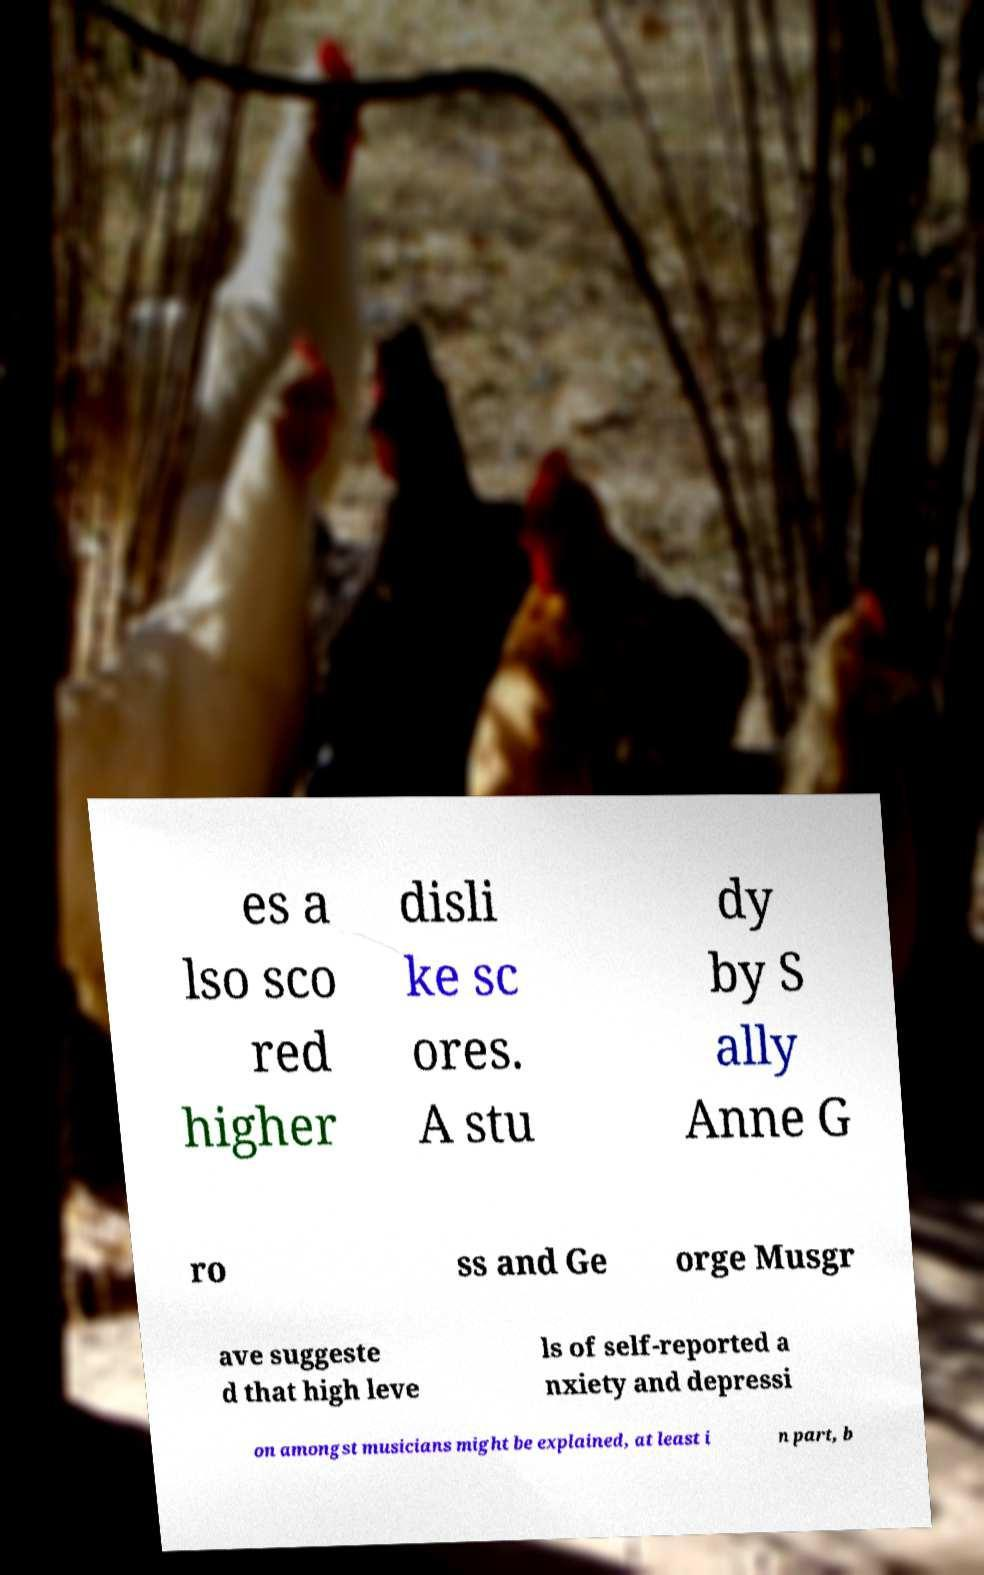Can you accurately transcribe the text from the provided image for me? es a lso sco red higher disli ke sc ores. A stu dy by S ally Anne G ro ss and Ge orge Musgr ave suggeste d that high leve ls of self-reported a nxiety and depressi on amongst musicians might be explained, at least i n part, b 